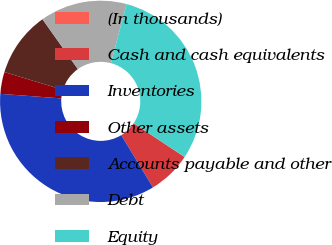Convert chart to OTSL. <chart><loc_0><loc_0><loc_500><loc_500><pie_chart><fcel>(In thousands)<fcel>Cash and cash equivalents<fcel>Inventories<fcel>Other assets<fcel>Accounts payable and other<fcel>Debt<fcel>Equity<nl><fcel>0.02%<fcel>6.99%<fcel>34.87%<fcel>3.51%<fcel>10.48%<fcel>13.96%<fcel>30.17%<nl></chart> 